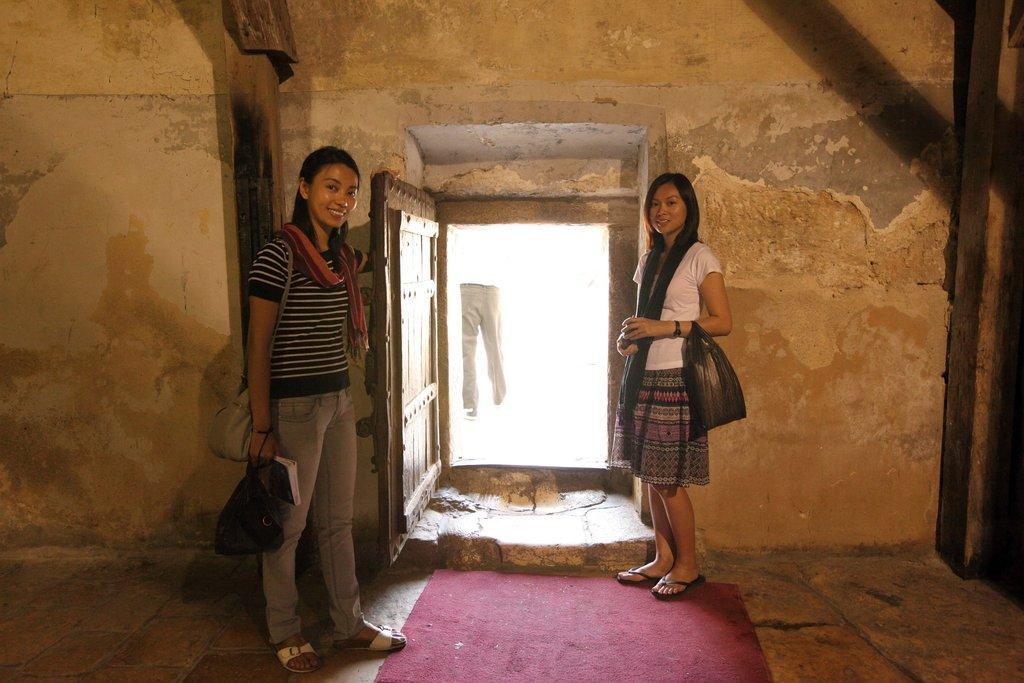Describe this image in one or two sentences. In this image there are two girls standing on the floor inside the room. In between them there is a door. On the right side there is a pillar. At the bottom there is a red color carpet on the floor. 